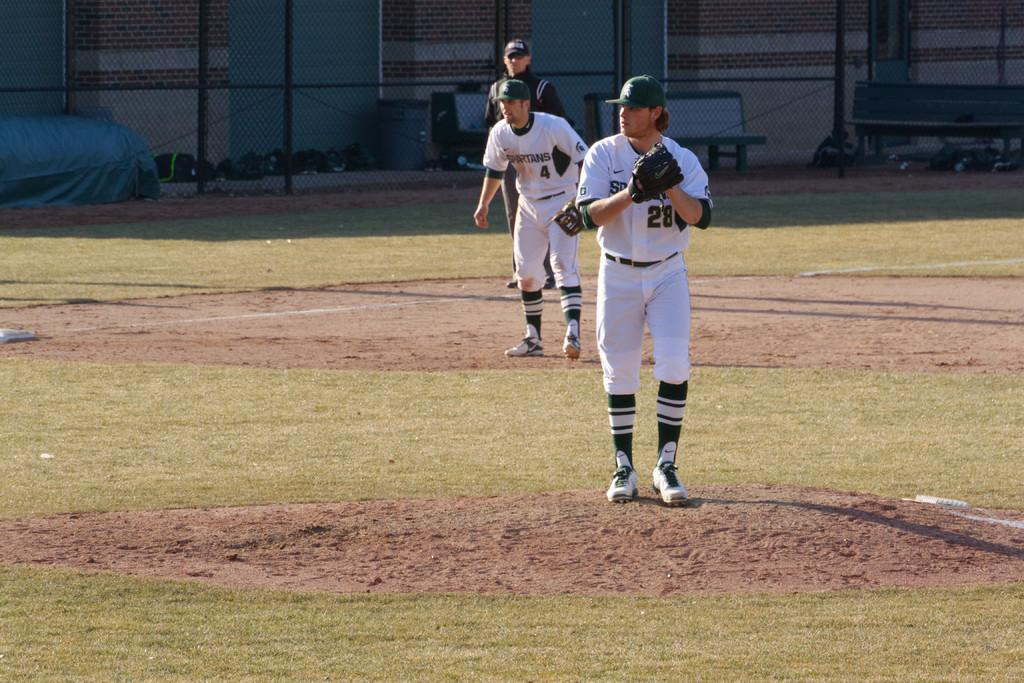<image>
Relay a brief, clear account of the picture shown. A man in a number 28 baseball uniform is setting up to pitch. 